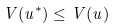<formula> <loc_0><loc_0><loc_500><loc_500>V ( u ^ { * } ) \leq V ( u )</formula> 